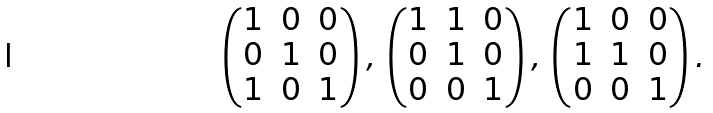<formula> <loc_0><loc_0><loc_500><loc_500>\begin{pmatrix} 1 & 0 & 0 \\ 0 & 1 & 0 \\ 1 & 0 & 1 \end{pmatrix} , \, \begin{pmatrix} 1 & 1 & 0 \\ 0 & 1 & 0 \\ 0 & 0 & 1 \end{pmatrix} , \, \begin{pmatrix} 1 & 0 & 0 \\ 1 & 1 & 0 \\ 0 & 0 & 1 \end{pmatrix} .</formula> 